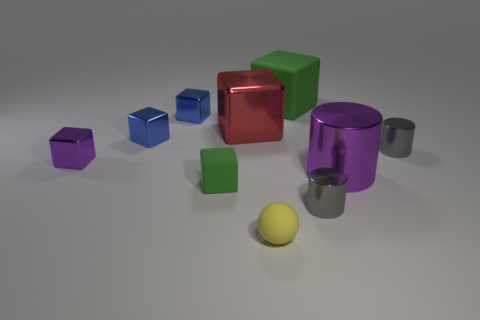Subtract all purple metal cubes. How many cubes are left? 5 Subtract all green cubes. How many cubes are left? 4 Subtract 3 blocks. How many blocks are left? 3 Subtract all yellow blocks. Subtract all blue spheres. How many blocks are left? 6 Subtract all cylinders. How many objects are left? 7 Add 7 yellow shiny cylinders. How many yellow shiny cylinders exist? 7 Subtract 0 brown blocks. How many objects are left? 10 Subtract all red rubber cubes. Subtract all small gray metal objects. How many objects are left? 8 Add 4 gray cylinders. How many gray cylinders are left? 6 